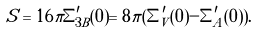<formula> <loc_0><loc_0><loc_500><loc_500>S = 1 6 \pi \Sigma ^ { \prime } _ { 3 B } ( 0 ) = 8 \pi ( \Sigma ^ { \prime } _ { V } ( 0 ) - \Sigma ^ { \prime } _ { A } ( 0 ) ) .</formula> 